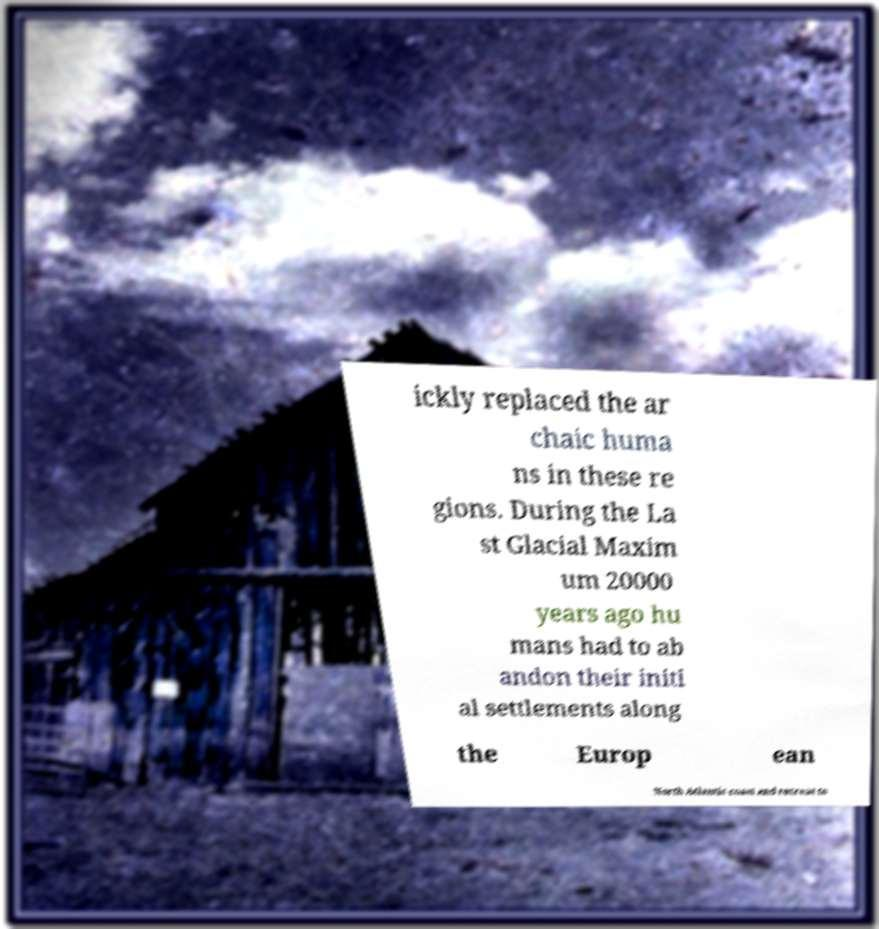Can you accurately transcribe the text from the provided image for me? ickly replaced the ar chaic huma ns in these re gions. During the La st Glacial Maxim um 20000 years ago hu mans had to ab andon their initi al settlements along the Europ ean North Atlantic coast and retreat to 